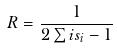<formula> <loc_0><loc_0><loc_500><loc_500>R = \frac { 1 } { 2 \sum i s _ { i } - 1 }</formula> 